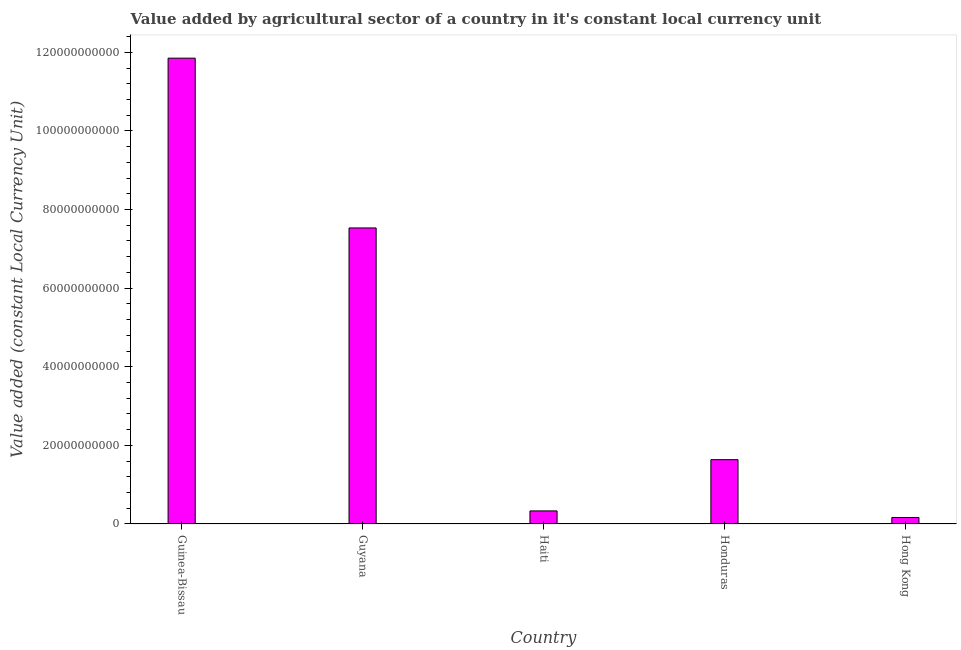Does the graph contain any zero values?
Your answer should be compact. No. What is the title of the graph?
Your response must be concise. Value added by agricultural sector of a country in it's constant local currency unit. What is the label or title of the Y-axis?
Your response must be concise. Value added (constant Local Currency Unit). What is the value added by agriculture sector in Guinea-Bissau?
Make the answer very short. 1.19e+11. Across all countries, what is the maximum value added by agriculture sector?
Your answer should be compact. 1.19e+11. Across all countries, what is the minimum value added by agriculture sector?
Ensure brevity in your answer.  1.66e+09. In which country was the value added by agriculture sector maximum?
Your answer should be very brief. Guinea-Bissau. In which country was the value added by agriculture sector minimum?
Your response must be concise. Hong Kong. What is the sum of the value added by agriculture sector?
Offer a terse response. 2.15e+11. What is the difference between the value added by agriculture sector in Guyana and Hong Kong?
Provide a short and direct response. 7.37e+1. What is the average value added by agriculture sector per country?
Your answer should be very brief. 4.30e+1. What is the median value added by agriculture sector?
Your answer should be compact. 1.64e+1. In how many countries, is the value added by agriculture sector greater than 80000000000 LCU?
Provide a succinct answer. 1. What is the ratio of the value added by agriculture sector in Guinea-Bissau to that in Guyana?
Provide a succinct answer. 1.57. What is the difference between the highest and the second highest value added by agriculture sector?
Offer a terse response. 4.32e+1. Is the sum of the value added by agriculture sector in Guinea-Bissau and Hong Kong greater than the maximum value added by agriculture sector across all countries?
Your response must be concise. Yes. What is the difference between the highest and the lowest value added by agriculture sector?
Keep it short and to the point. 1.17e+11. In how many countries, is the value added by agriculture sector greater than the average value added by agriculture sector taken over all countries?
Make the answer very short. 2. Are all the bars in the graph horizontal?
Offer a terse response. No. How many countries are there in the graph?
Your answer should be compact. 5. What is the Value added (constant Local Currency Unit) of Guinea-Bissau?
Your answer should be compact. 1.19e+11. What is the Value added (constant Local Currency Unit) in Guyana?
Your answer should be compact. 7.53e+1. What is the Value added (constant Local Currency Unit) in Haiti?
Your answer should be compact. 3.33e+09. What is the Value added (constant Local Currency Unit) in Honduras?
Give a very brief answer. 1.64e+1. What is the Value added (constant Local Currency Unit) of Hong Kong?
Your response must be concise. 1.66e+09. What is the difference between the Value added (constant Local Currency Unit) in Guinea-Bissau and Guyana?
Give a very brief answer. 4.32e+1. What is the difference between the Value added (constant Local Currency Unit) in Guinea-Bissau and Haiti?
Your answer should be very brief. 1.15e+11. What is the difference between the Value added (constant Local Currency Unit) in Guinea-Bissau and Honduras?
Your answer should be very brief. 1.02e+11. What is the difference between the Value added (constant Local Currency Unit) in Guinea-Bissau and Hong Kong?
Your response must be concise. 1.17e+11. What is the difference between the Value added (constant Local Currency Unit) in Guyana and Haiti?
Give a very brief answer. 7.20e+1. What is the difference between the Value added (constant Local Currency Unit) in Guyana and Honduras?
Provide a succinct answer. 5.90e+1. What is the difference between the Value added (constant Local Currency Unit) in Guyana and Hong Kong?
Offer a terse response. 7.37e+1. What is the difference between the Value added (constant Local Currency Unit) in Haiti and Honduras?
Keep it short and to the point. -1.30e+1. What is the difference between the Value added (constant Local Currency Unit) in Haiti and Hong Kong?
Your response must be concise. 1.67e+09. What is the difference between the Value added (constant Local Currency Unit) in Honduras and Hong Kong?
Offer a terse response. 1.47e+1. What is the ratio of the Value added (constant Local Currency Unit) in Guinea-Bissau to that in Guyana?
Give a very brief answer. 1.57. What is the ratio of the Value added (constant Local Currency Unit) in Guinea-Bissau to that in Haiti?
Give a very brief answer. 35.63. What is the ratio of the Value added (constant Local Currency Unit) in Guinea-Bissau to that in Honduras?
Make the answer very short. 7.25. What is the ratio of the Value added (constant Local Currency Unit) in Guinea-Bissau to that in Hong Kong?
Offer a very short reply. 71.57. What is the ratio of the Value added (constant Local Currency Unit) in Guyana to that in Haiti?
Your answer should be very brief. 22.65. What is the ratio of the Value added (constant Local Currency Unit) in Guyana to that in Honduras?
Your answer should be very brief. 4.6. What is the ratio of the Value added (constant Local Currency Unit) in Guyana to that in Hong Kong?
Your response must be concise. 45.48. What is the ratio of the Value added (constant Local Currency Unit) in Haiti to that in Honduras?
Keep it short and to the point. 0.2. What is the ratio of the Value added (constant Local Currency Unit) in Haiti to that in Hong Kong?
Your response must be concise. 2.01. What is the ratio of the Value added (constant Local Currency Unit) in Honduras to that in Hong Kong?
Offer a very short reply. 9.88. 